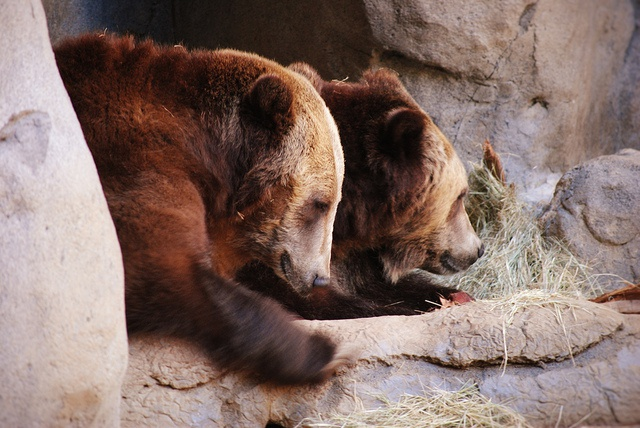Describe the objects in this image and their specific colors. I can see bear in darkgray, black, maroon, brown, and tan tones and bear in darkgray, black, maroon, brown, and tan tones in this image. 